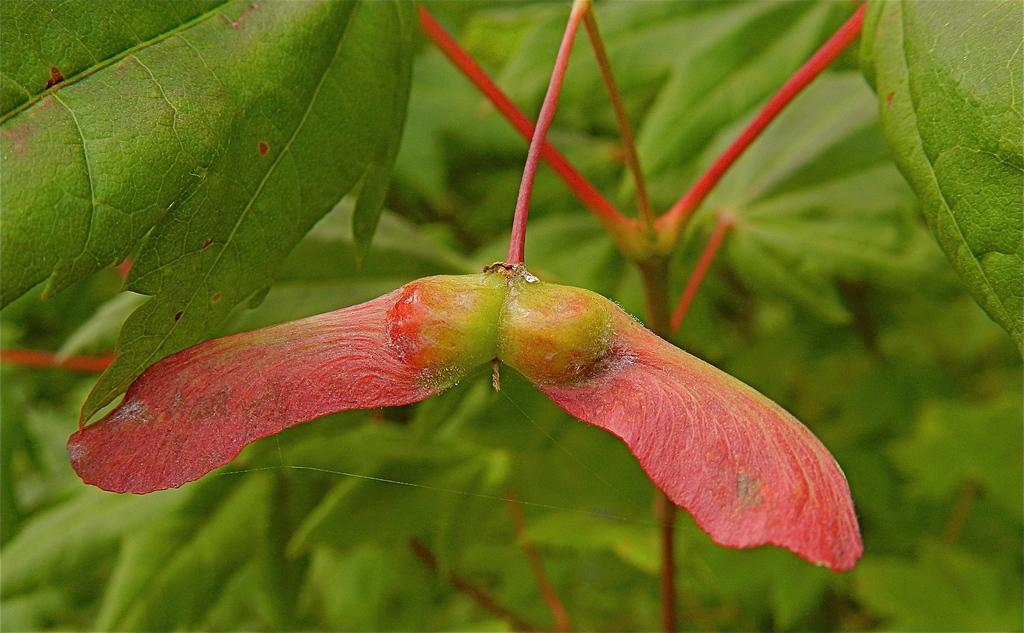What type of living organisms can be seen in the image? Plants and a flower are visible in the image. What color is the flower in the image? The flower in the image is pink. Where is the toothpaste located in the image? There is no toothpaste present in the image. What type of stage can be seen in the image? There is no stage present in the image. 